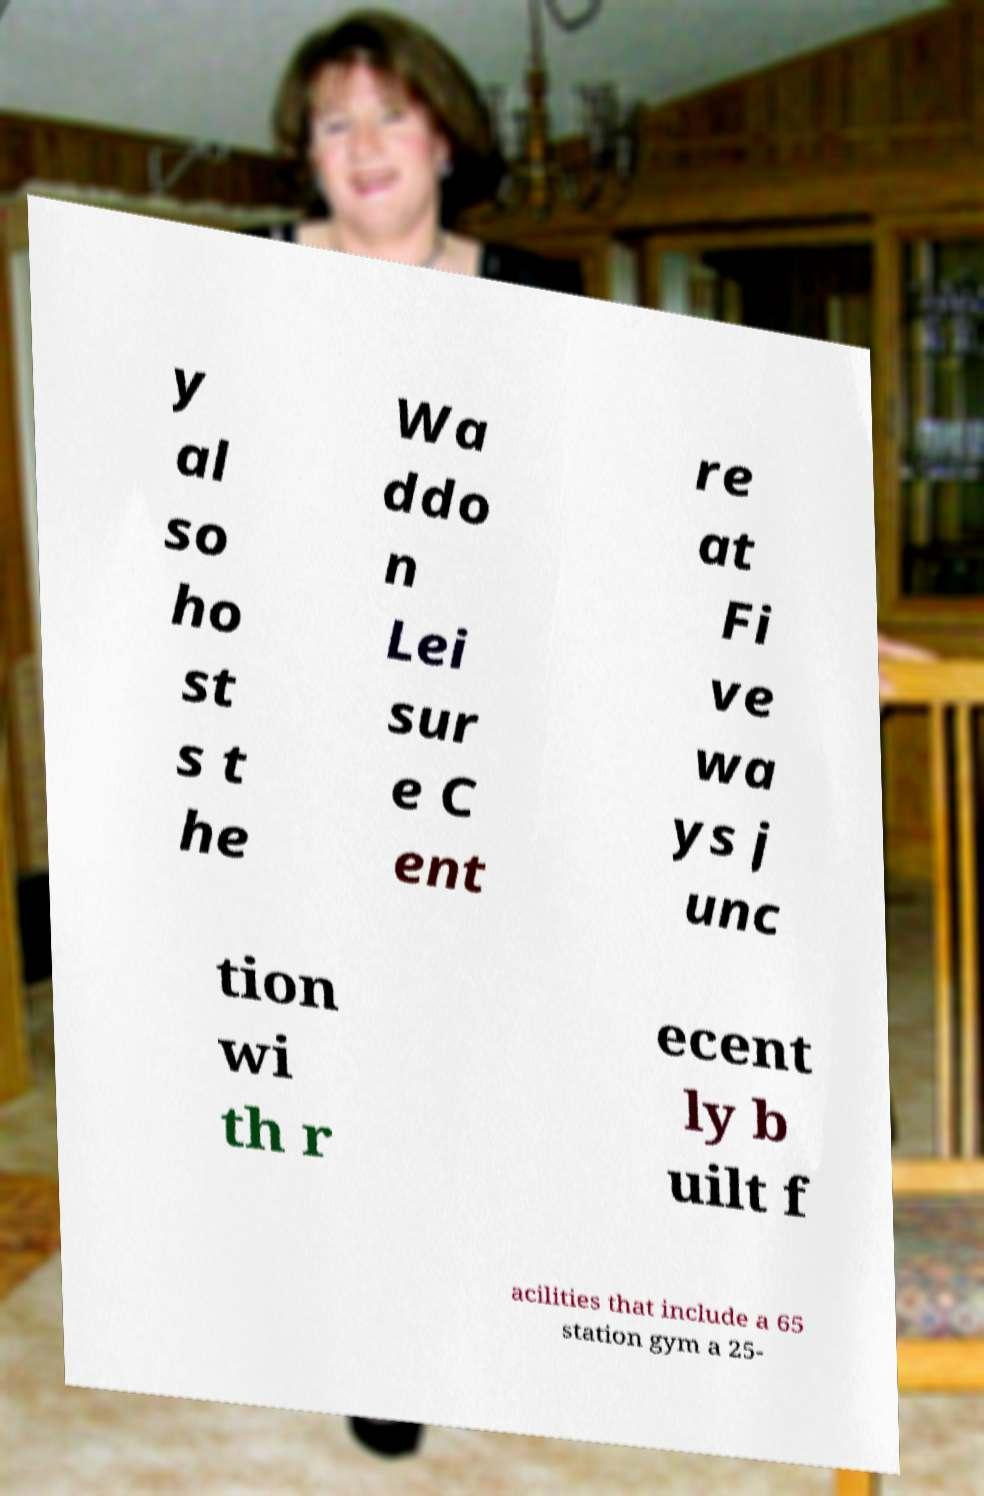There's text embedded in this image that I need extracted. Can you transcribe it verbatim? y al so ho st s t he Wa ddo n Lei sur e C ent re at Fi ve wa ys j unc tion wi th r ecent ly b uilt f acilities that include a 65 station gym a 25- 